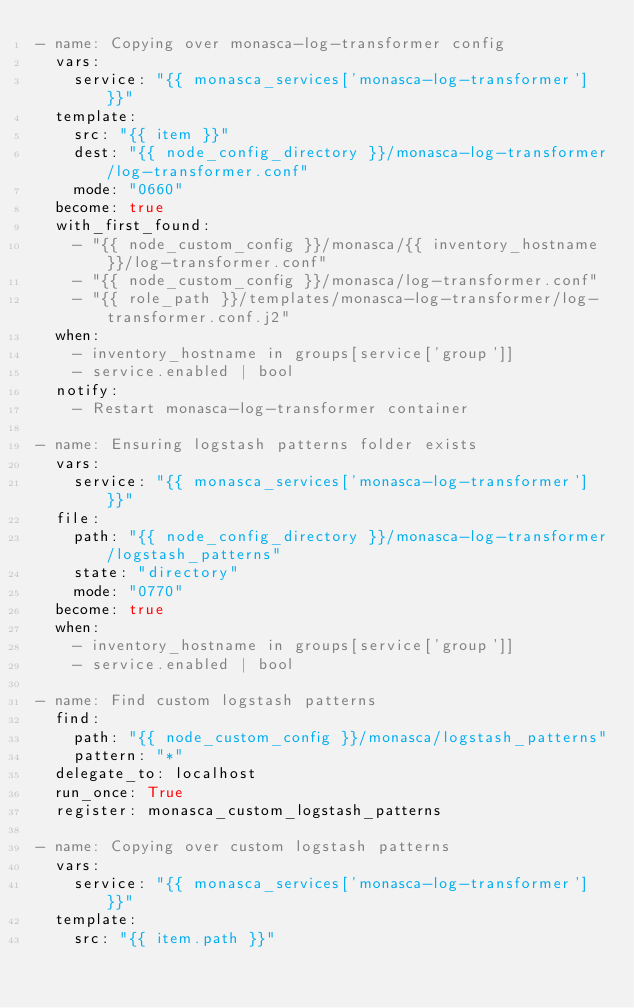Convert code to text. <code><loc_0><loc_0><loc_500><loc_500><_YAML_>- name: Copying over monasca-log-transformer config
  vars:
    service: "{{ monasca_services['monasca-log-transformer'] }}"
  template:
    src: "{{ item }}"
    dest: "{{ node_config_directory }}/monasca-log-transformer/log-transformer.conf"
    mode: "0660"
  become: true
  with_first_found:
    - "{{ node_custom_config }}/monasca/{{ inventory_hostname }}/log-transformer.conf"
    - "{{ node_custom_config }}/monasca/log-transformer.conf"
    - "{{ role_path }}/templates/monasca-log-transformer/log-transformer.conf.j2"
  when:
    - inventory_hostname in groups[service['group']]
    - service.enabled | bool
  notify:
    - Restart monasca-log-transformer container

- name: Ensuring logstash patterns folder exists
  vars:
    service: "{{ monasca_services['monasca-log-transformer'] }}"
  file:
    path: "{{ node_config_directory }}/monasca-log-transformer/logstash_patterns"
    state: "directory"
    mode: "0770"
  become: true
  when:
    - inventory_hostname in groups[service['group']]
    - service.enabled | bool

- name: Find custom logstash patterns
  find:
    path: "{{ node_custom_config }}/monasca/logstash_patterns"
    pattern: "*"
  delegate_to: localhost
  run_once: True
  register: monasca_custom_logstash_patterns

- name: Copying over custom logstash patterns
  vars:
    service: "{{ monasca_services['monasca-log-transformer'] }}"
  template:
    src: "{{ item.path }}"</code> 